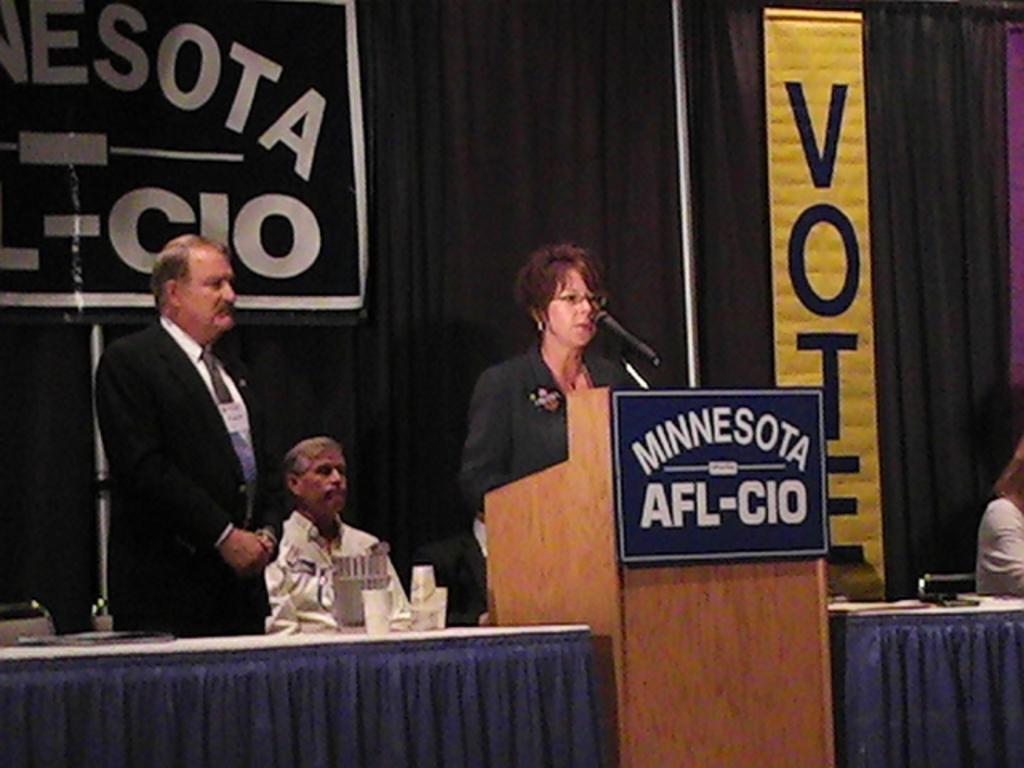Describe this image in one or two sentences. This image is taken indoors. In the background there are a few curtains and banners with text on them. At the bottom of the image there is a table with table clothes and a few things on them and there is a podium with a mic and a board with text on it. In the middle of the image a woman is standing on the floor and a man is sitting on the chair. On the right side a person is sitting on the chair. On the left side of the image a man is standing on the floor. 